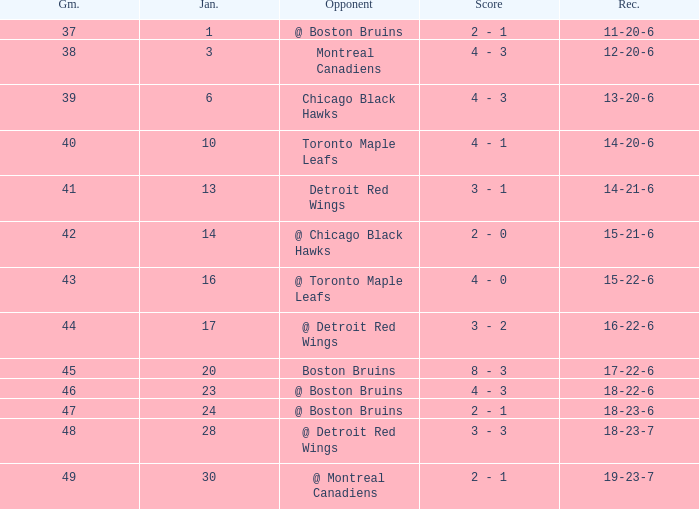Who was the opponent with the record of 15-21-6? @ Chicago Black Hawks. 